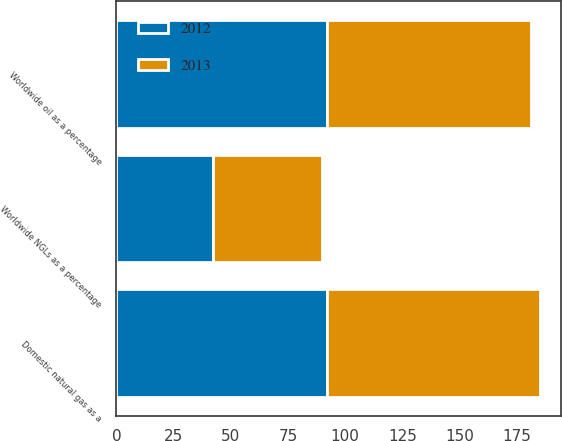<chart> <loc_0><loc_0><loc_500><loc_500><stacked_bar_chart><ecel><fcel>Worldwide oil as a percentage<fcel>Worldwide NGLs as a percentage<fcel>Domestic natural gas as a<nl><fcel>2012<fcel>92<fcel>42<fcel>92<nl><fcel>2013<fcel>89<fcel>48<fcel>93<nl></chart> 